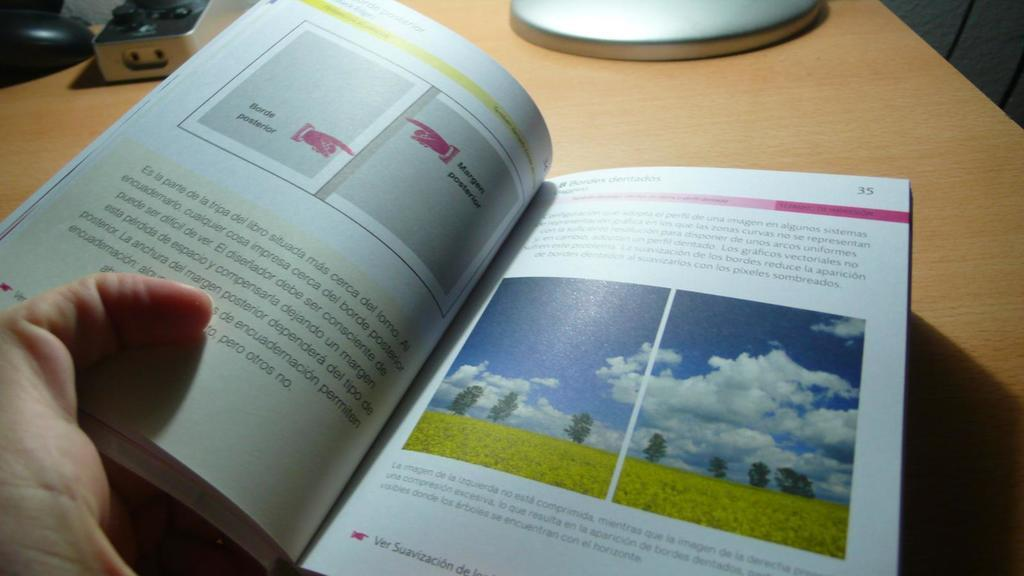<image>
Give a short and clear explanation of the subsequent image. a book opened up to page 35 with pictures of sky and grass on them 